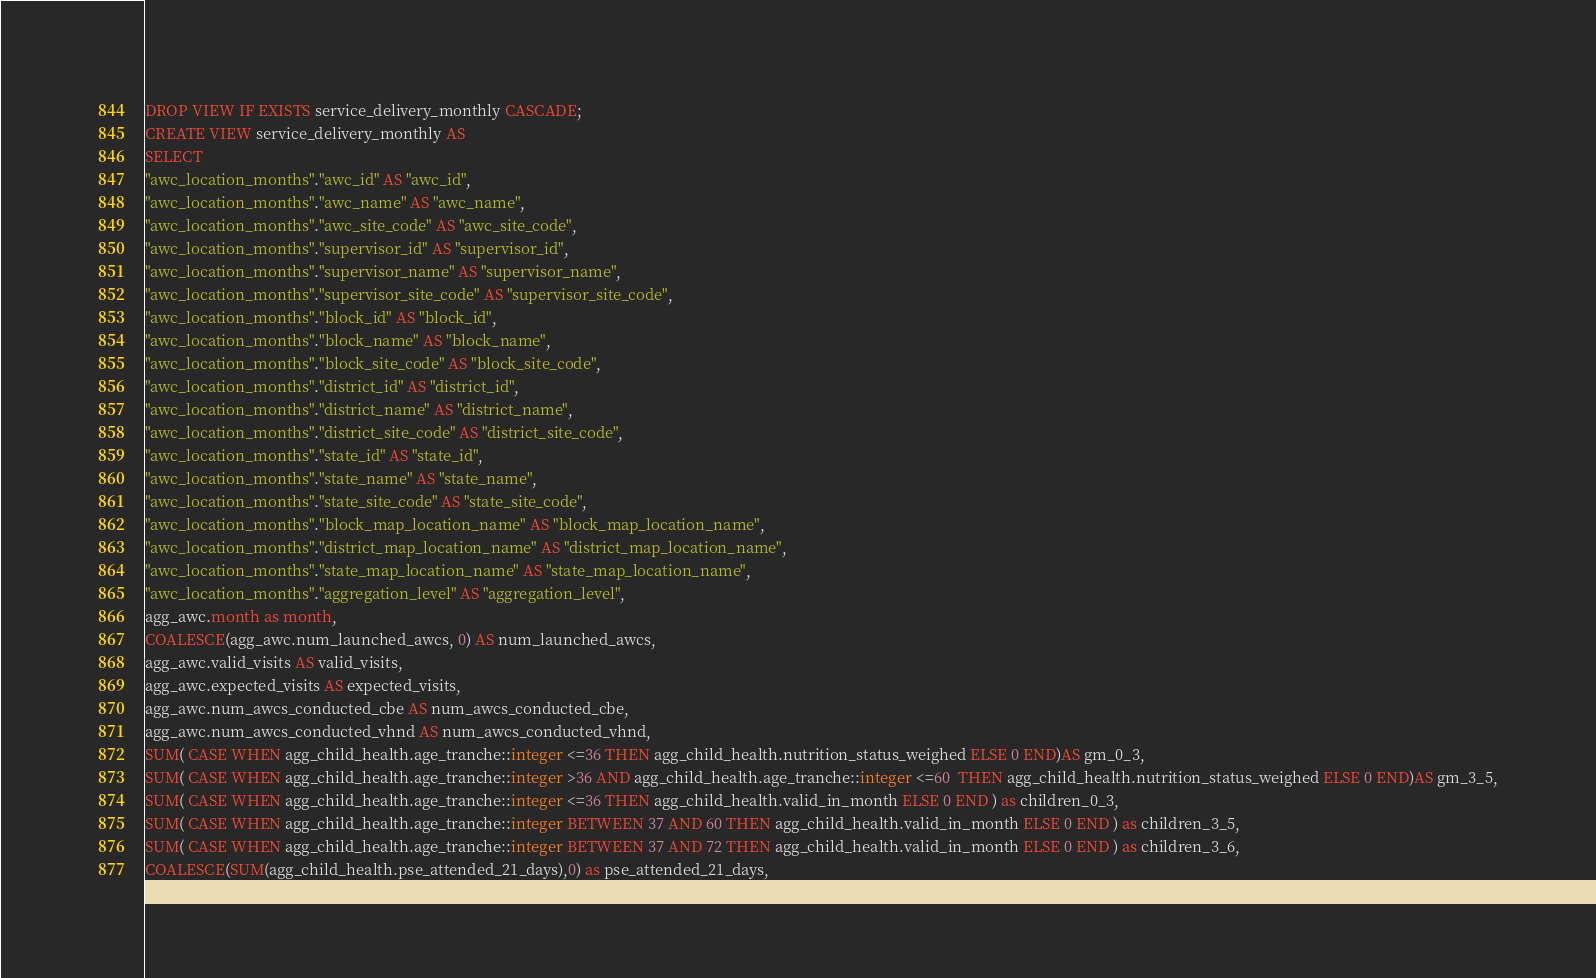Convert code to text. <code><loc_0><loc_0><loc_500><loc_500><_SQL_>DROP VIEW IF EXISTS service_delivery_monthly CASCADE;
CREATE VIEW service_delivery_monthly AS
SELECT
"awc_location_months"."awc_id" AS "awc_id",
"awc_location_months"."awc_name" AS "awc_name",
"awc_location_months"."awc_site_code" AS "awc_site_code",
"awc_location_months"."supervisor_id" AS "supervisor_id",
"awc_location_months"."supervisor_name" AS "supervisor_name",
"awc_location_months"."supervisor_site_code" AS "supervisor_site_code",
"awc_location_months"."block_id" AS "block_id",
"awc_location_months"."block_name" AS "block_name",
"awc_location_months"."block_site_code" AS "block_site_code",
"awc_location_months"."district_id" AS "district_id",
"awc_location_months"."district_name" AS "district_name",
"awc_location_months"."district_site_code" AS "district_site_code",
"awc_location_months"."state_id" AS "state_id",
"awc_location_months"."state_name" AS "state_name",
"awc_location_months"."state_site_code" AS "state_site_code",
"awc_location_months"."block_map_location_name" AS "block_map_location_name",
"awc_location_months"."district_map_location_name" AS "district_map_location_name",
"awc_location_months"."state_map_location_name" AS "state_map_location_name",
"awc_location_months"."aggregation_level" AS "aggregation_level",
agg_awc.month as month,
COALESCE(agg_awc.num_launched_awcs, 0) AS num_launched_awcs,
agg_awc.valid_visits AS valid_visits,
agg_awc.expected_visits AS expected_visits,
agg_awc.num_awcs_conducted_cbe AS num_awcs_conducted_cbe,
agg_awc.num_awcs_conducted_vhnd AS num_awcs_conducted_vhnd,
SUM( CASE WHEN agg_child_health.age_tranche::integer <=36 THEN agg_child_health.nutrition_status_weighed ELSE 0 END)AS gm_0_3,
SUM( CASE WHEN agg_child_health.age_tranche::integer >36 AND agg_child_health.age_tranche::integer <=60  THEN agg_child_health.nutrition_status_weighed ELSE 0 END)AS gm_3_5,
SUM( CASE WHEN agg_child_health.age_tranche::integer <=36 THEN agg_child_health.valid_in_month ELSE 0 END ) as children_0_3,
SUM( CASE WHEN agg_child_health.age_tranche::integer BETWEEN 37 AND 60 THEN agg_child_health.valid_in_month ELSE 0 END ) as children_3_5,
SUM( CASE WHEN agg_child_health.age_tranche::integer BETWEEN 37 AND 72 THEN agg_child_health.valid_in_month ELSE 0 END ) as children_3_6,
COALESCE(SUM(agg_child_health.pse_attended_21_days),0) as pse_attended_21_days,</code> 